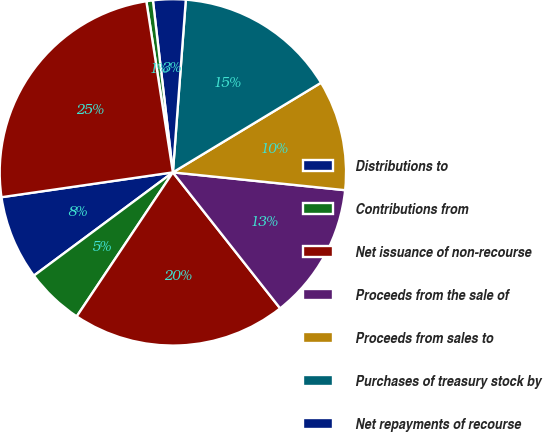Convert chart. <chart><loc_0><loc_0><loc_500><loc_500><pie_chart><fcel>Distributions to<fcel>Contributions from<fcel>Net issuance of non-recourse<fcel>Proceeds from the sale of<fcel>Proceeds from sales to<fcel>Purchases of treasury stock by<fcel>Net repayments of recourse<fcel>Other financing activities<fcel>Total increase in net cash<nl><fcel>7.88%<fcel>5.46%<fcel>20.0%<fcel>12.73%<fcel>10.3%<fcel>15.15%<fcel>3.03%<fcel>0.61%<fcel>24.84%<nl></chart> 